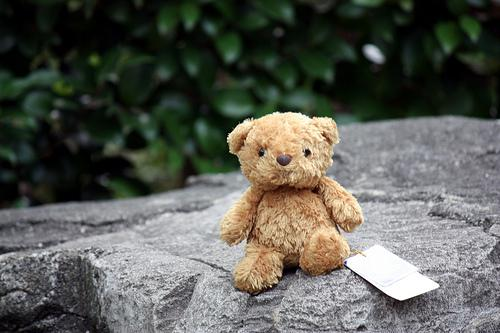Question: what color is the bear?
Choices:
A. Black.
B. Tan.
C. Brown.
D. White.
Answer with the letter. Answer: B Question: where is the rock?
Choices:
A. In the woods.
B. Under the bear.
C. By the river.
D. In the park.
Answer with the letter. Answer: B Question: how many eyes does the teddy bear have?
Choices:
A. One.
B. Two.
C. Three.
D. None.
Answer with the letter. Answer: B Question: why are there plants behind the bear?
Choices:
A. Decorations.
B. For food.
C. In woods.
D. It is outside.
Answer with the letter. Answer: D 